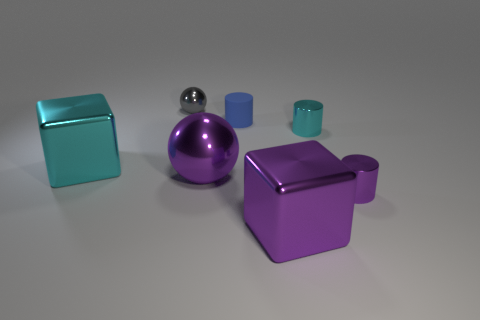The metallic cylinder that is the same color as the big sphere is what size?
Provide a succinct answer. Small. There is a tiny cyan object; is it the same shape as the large purple shiny object to the left of the blue cylinder?
Your response must be concise. No. What is the tiny blue object made of?
Give a very brief answer. Rubber. How many metallic things are either tiny cyan cylinders or cylinders?
Keep it short and to the point. 2. Are there fewer blue rubber cylinders that are behind the small metal sphere than gray metal balls right of the cyan metallic cylinder?
Your answer should be compact. No. There is a ball that is in front of the cube to the left of the purple ball; are there any blue cylinders that are to the right of it?
Your response must be concise. Yes. What material is the large cube that is the same color as the large sphere?
Your response must be concise. Metal. There is a big purple object that is right of the large purple ball; is it the same shape as the cyan object right of the tiny gray ball?
Keep it short and to the point. No. There is another cyan thing that is the same size as the rubber object; what is its material?
Offer a terse response. Metal. Is the material of the large object in front of the big ball the same as the large cube to the left of the tiny blue matte cylinder?
Provide a succinct answer. Yes. 